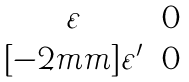Convert formula to latex. <formula><loc_0><loc_0><loc_500><loc_500>\begin{matrix} \varepsilon & 0 \\ [ - 2 m m ] \varepsilon ^ { \prime } & 0 \end{matrix}</formula> 